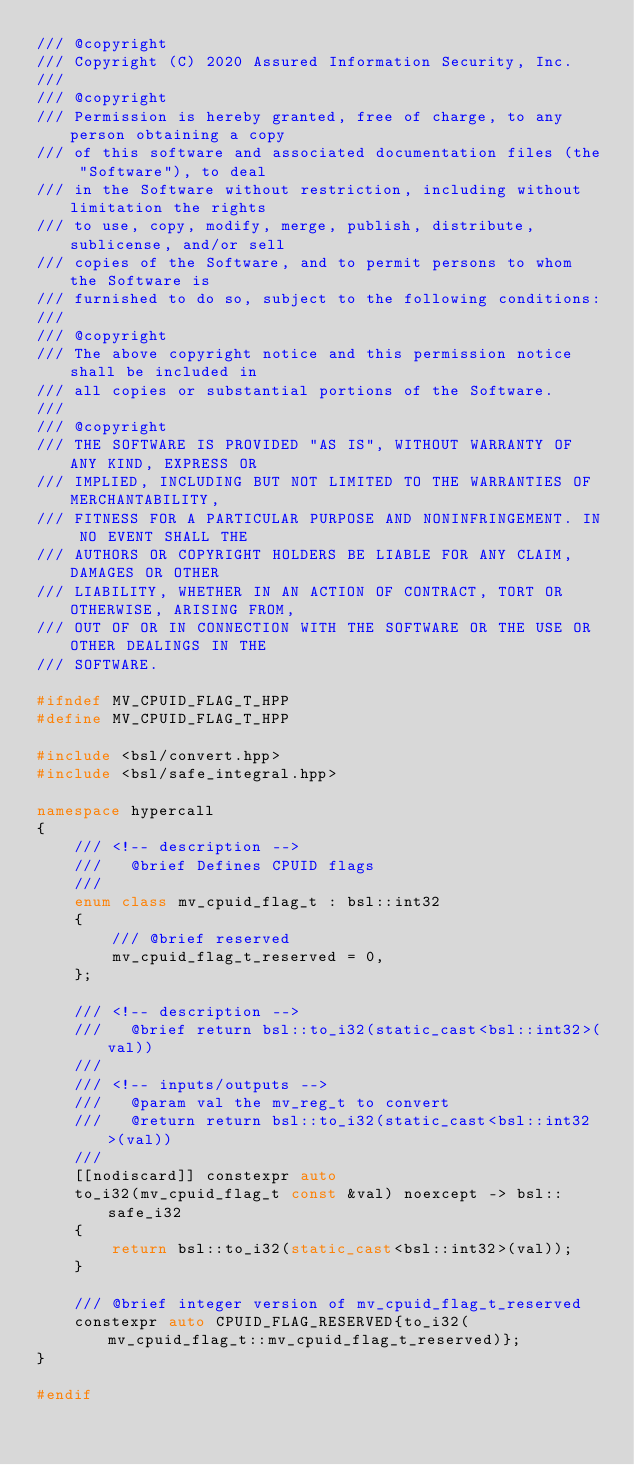Convert code to text. <code><loc_0><loc_0><loc_500><loc_500><_C++_>/// @copyright
/// Copyright (C) 2020 Assured Information Security, Inc.
///
/// @copyright
/// Permission is hereby granted, free of charge, to any person obtaining a copy
/// of this software and associated documentation files (the "Software"), to deal
/// in the Software without restriction, including without limitation the rights
/// to use, copy, modify, merge, publish, distribute, sublicense, and/or sell
/// copies of the Software, and to permit persons to whom the Software is
/// furnished to do so, subject to the following conditions:
///
/// @copyright
/// The above copyright notice and this permission notice shall be included in
/// all copies or substantial portions of the Software.
///
/// @copyright
/// THE SOFTWARE IS PROVIDED "AS IS", WITHOUT WARRANTY OF ANY KIND, EXPRESS OR
/// IMPLIED, INCLUDING BUT NOT LIMITED TO THE WARRANTIES OF MERCHANTABILITY,
/// FITNESS FOR A PARTICULAR PURPOSE AND NONINFRINGEMENT. IN NO EVENT SHALL THE
/// AUTHORS OR COPYRIGHT HOLDERS BE LIABLE FOR ANY CLAIM, DAMAGES OR OTHER
/// LIABILITY, WHETHER IN AN ACTION OF CONTRACT, TORT OR OTHERWISE, ARISING FROM,
/// OUT OF OR IN CONNECTION WITH THE SOFTWARE OR THE USE OR OTHER DEALINGS IN THE
/// SOFTWARE.

#ifndef MV_CPUID_FLAG_T_HPP
#define MV_CPUID_FLAG_T_HPP

#include <bsl/convert.hpp>
#include <bsl/safe_integral.hpp>

namespace hypercall
{
    /// <!-- description -->
    ///   @brief Defines CPUID flags
    ///
    enum class mv_cpuid_flag_t : bsl::int32
    {
        /// @brief reserved
        mv_cpuid_flag_t_reserved = 0,
    };

    /// <!-- description -->
    ///   @brief return bsl::to_i32(static_cast<bsl::int32>(val))
    ///
    /// <!-- inputs/outputs -->
    ///   @param val the mv_reg_t to convert
    ///   @return return bsl::to_i32(static_cast<bsl::int32>(val))
    ///
    [[nodiscard]] constexpr auto
    to_i32(mv_cpuid_flag_t const &val) noexcept -> bsl::safe_i32
    {
        return bsl::to_i32(static_cast<bsl::int32>(val));
    }

    /// @brief integer version of mv_cpuid_flag_t_reserved
    constexpr auto CPUID_FLAG_RESERVED{to_i32(mv_cpuid_flag_t::mv_cpuid_flag_t_reserved)};
}

#endif
</code> 